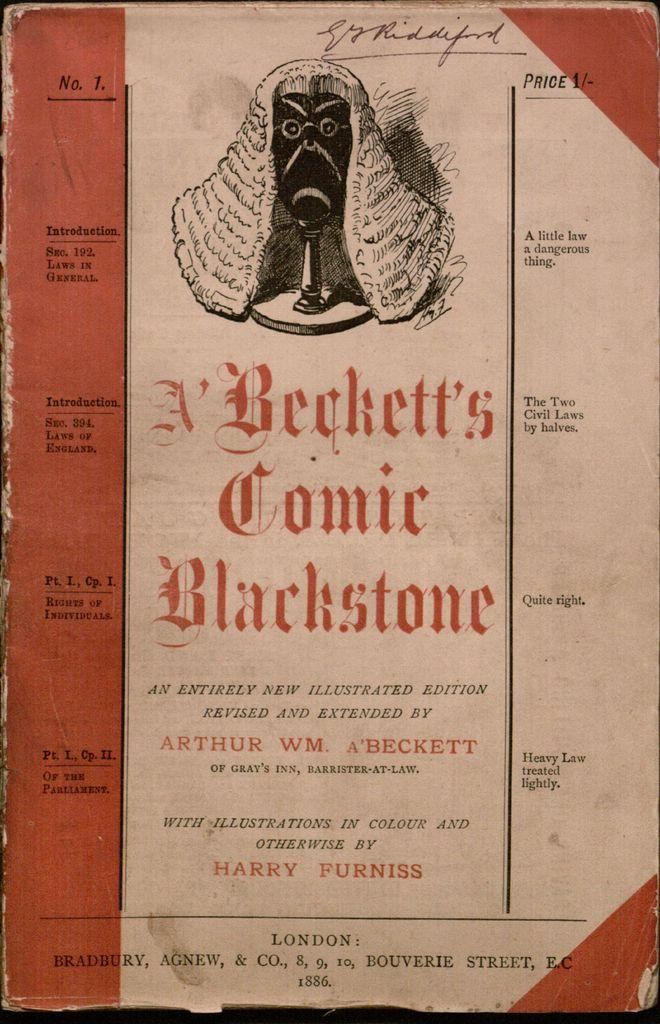<image>
Write a terse but informative summary of the picture. Pamphlet saying Beckett's Comic Blackstone, Revised and Extended by Arthur WM A'Beckett. 